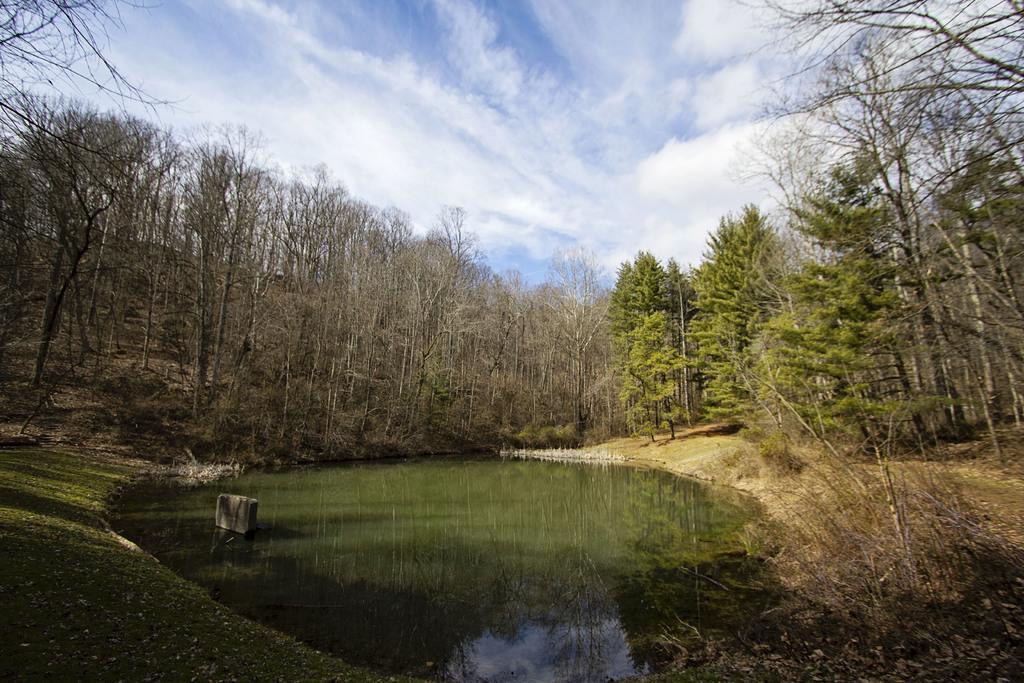Please provide a concise description of this image. In the center of the image there is a water and we can see trees. In the background there is sky. 